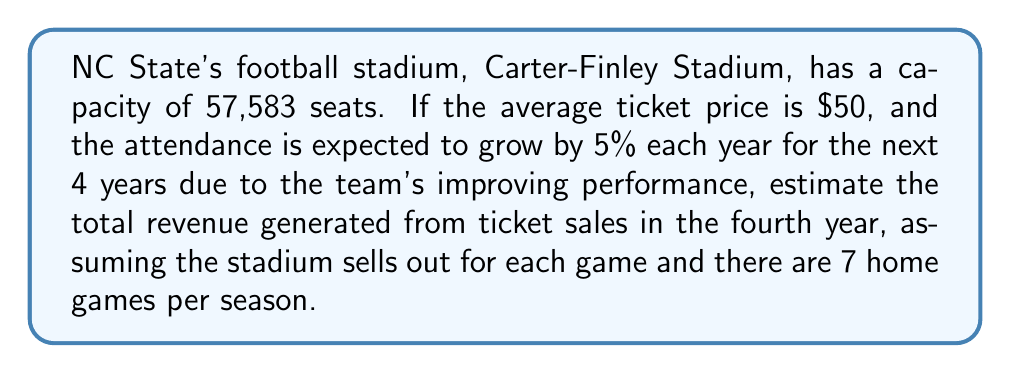Can you solve this math problem? Let's approach this problem step-by-step using an exponential growth model:

1) Initial attendance (year 0) = 57,583 (stadium capacity)
2) Growth rate = 5% = 0.05
3) Time period = 4 years
4) Number of home games per season = 7
5) Average ticket price = $50

The exponential growth formula is:
$$A = P(1 + r)^t$$
Where:
A = Final amount
P = Initial amount
r = Growth rate (as a decimal)
t = Time in years

For attendance in year 4:
$$A = 57,583(1 + 0.05)^4 = 57,583(1.05)^4 = 70,013.95$$

However, since we can't have a fractional attendance, we round down to 70,013.

Now, to calculate the revenue for one game:
$$\text{Revenue per game} = 70,013 \times \$50 = \$3,500,650$$

For the entire season (7 home games):
$$\text{Total revenue} = \$3,500,650 \times 7 = \$24,504,550$$
Answer: $24,504,550 